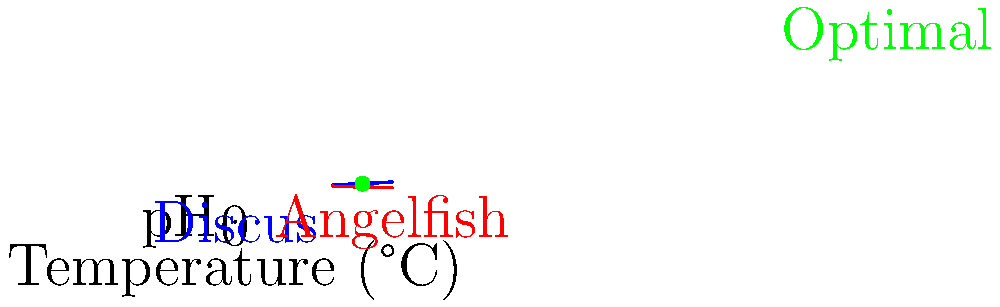Baserat på grafen som visar pH-nivåer och temperaturer för två populära exotiska akvariefiskar, diskusfisk och ängelfisk, vid vilken temperatur och pH-nivå möts de två linjerna, vilket indikerar en optimal miljö för att hålla båda arterna tillsammans? För att lösa detta problem, följer vi dessa steg:

1. Identifiera ekvationerna för de två linjerna:
   - Diskusfisk (blå linje): $y = 0.05x + 6.5$
   - Ängelfisk (röd linje): $y = -0.025x + 7.75$

2. För att hitta skärningspunkten, sätt ekvationerna lika med varandra:
   $0.05x + 6.5 = -0.025x + 7.75$

3. Lös ekvationen för x:
   $0.075x = 1.25$
   $x = 1.25 / 0.075 = 16.67$

4. Avrunda temperaturen till närmaste heltal:
   Temperatur = 26°C

5. Beräkna pH-värdet genom att sätta in temperaturen i någon av ekvationerna:
   $y = 0.05(26) + 6.5 = 7.8$

6. Verifiera resultatet genom att kontrollera den gröna punkten på grafen, som representerar den optimala miljön.
Answer: 26°C, pH 7.8 